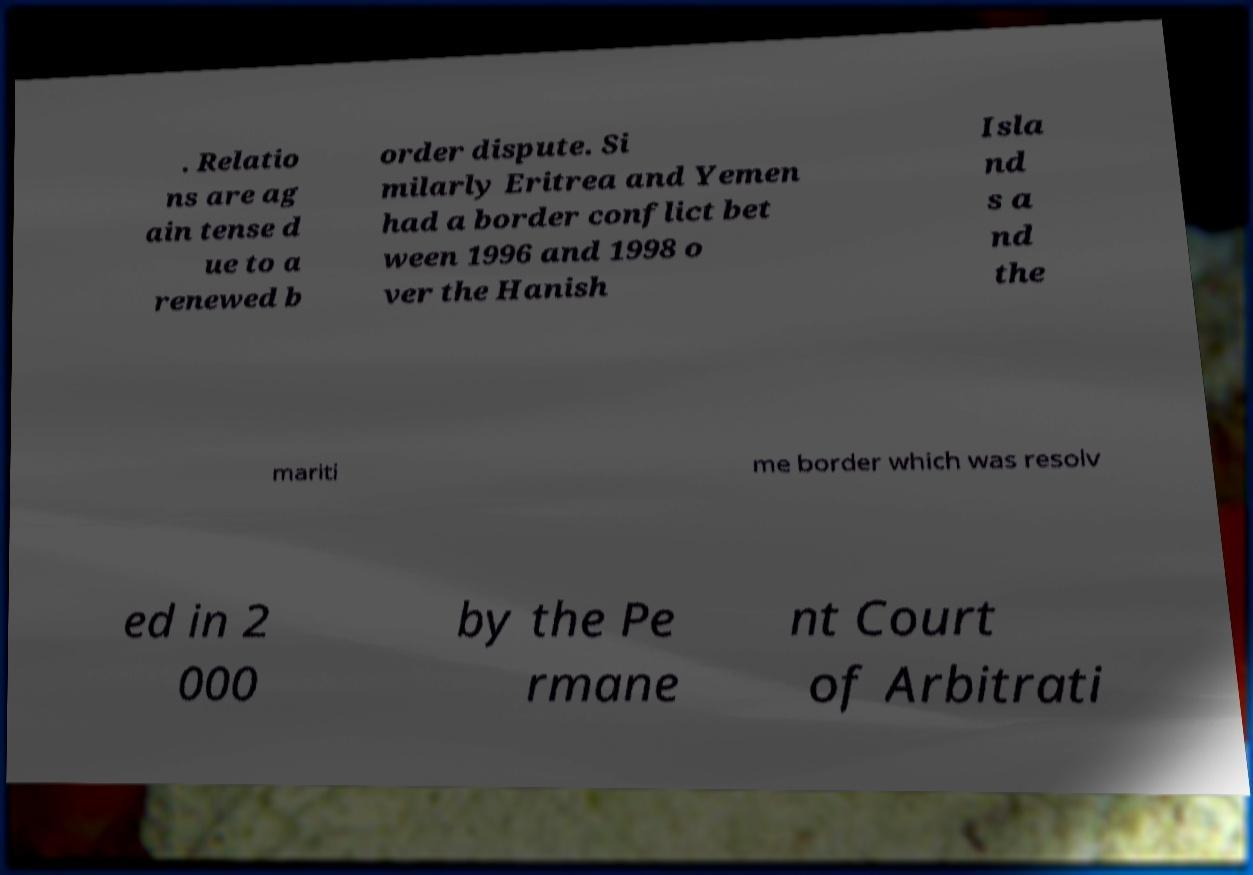What messages or text are displayed in this image? I need them in a readable, typed format. . Relatio ns are ag ain tense d ue to a renewed b order dispute. Si milarly Eritrea and Yemen had a border conflict bet ween 1996 and 1998 o ver the Hanish Isla nd s a nd the mariti me border which was resolv ed in 2 000 by the Pe rmane nt Court of Arbitrati 